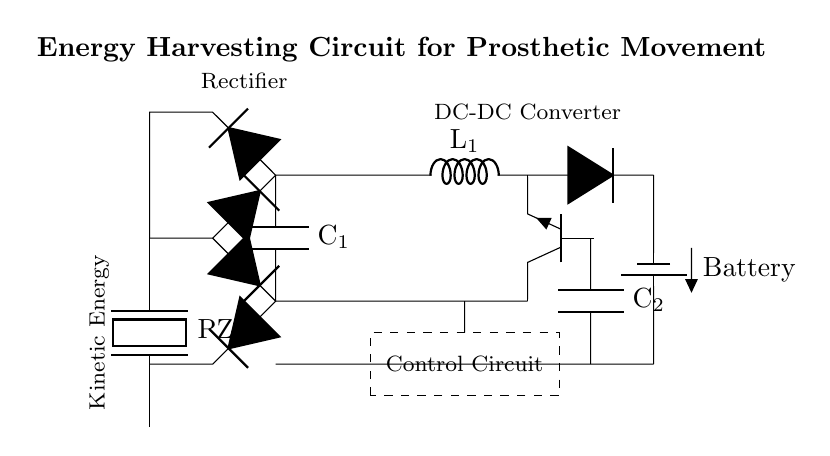What is the main component used to capture kinetic energy? The main component is a piezoelectric device, specifically labeled as PZT in the diagram. It converts mechanical strain from movement into electrical energy.
Answer: PZT What does the circuit primarily do? The circuit harvests kinetic energy from prosthetic movement to charge small batteries through various components including a rectifier and DC-DC converter.
Answer: Harvests energy How many diodes are used in the rectifier bridge? There are four diodes configured in the bridge as indicated by the parallel and series arrangements in the rectifier section.
Answer: Four What type of capacitor is shown in the smoothing capacitor section? The capacitor shown is labeled C1, and it is used to smooth the output voltage after rectification, indicative of its role in filtering fluctuations.
Answer: C1 What is the purpose of the control circuit in the diagram? The control circuit manages the overall operation of the energy harvesting system ensuring efficient charging and regulation of energy flow to the battery.
Answer: Management What is the output voltage of the battery? The output voltage is not explicitly stated, but it can be inferred that it is determined by the preceding components which regulate the voltage to be suitable for charging.
Answer: Not specified What role does the inductor play in the circuit? The inductor, labeled L1, is crucial for energy storage, smoothening current flow, and preventing voltage spikes during the switching process in the DC-DC converter section.
Answer: Energy storage 